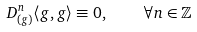<formula> <loc_0><loc_0><loc_500><loc_500>D _ { ( g ) } ^ { n } \langle g , g \rangle \equiv 0 , \quad \forall n \in \mathbb { Z }</formula> 